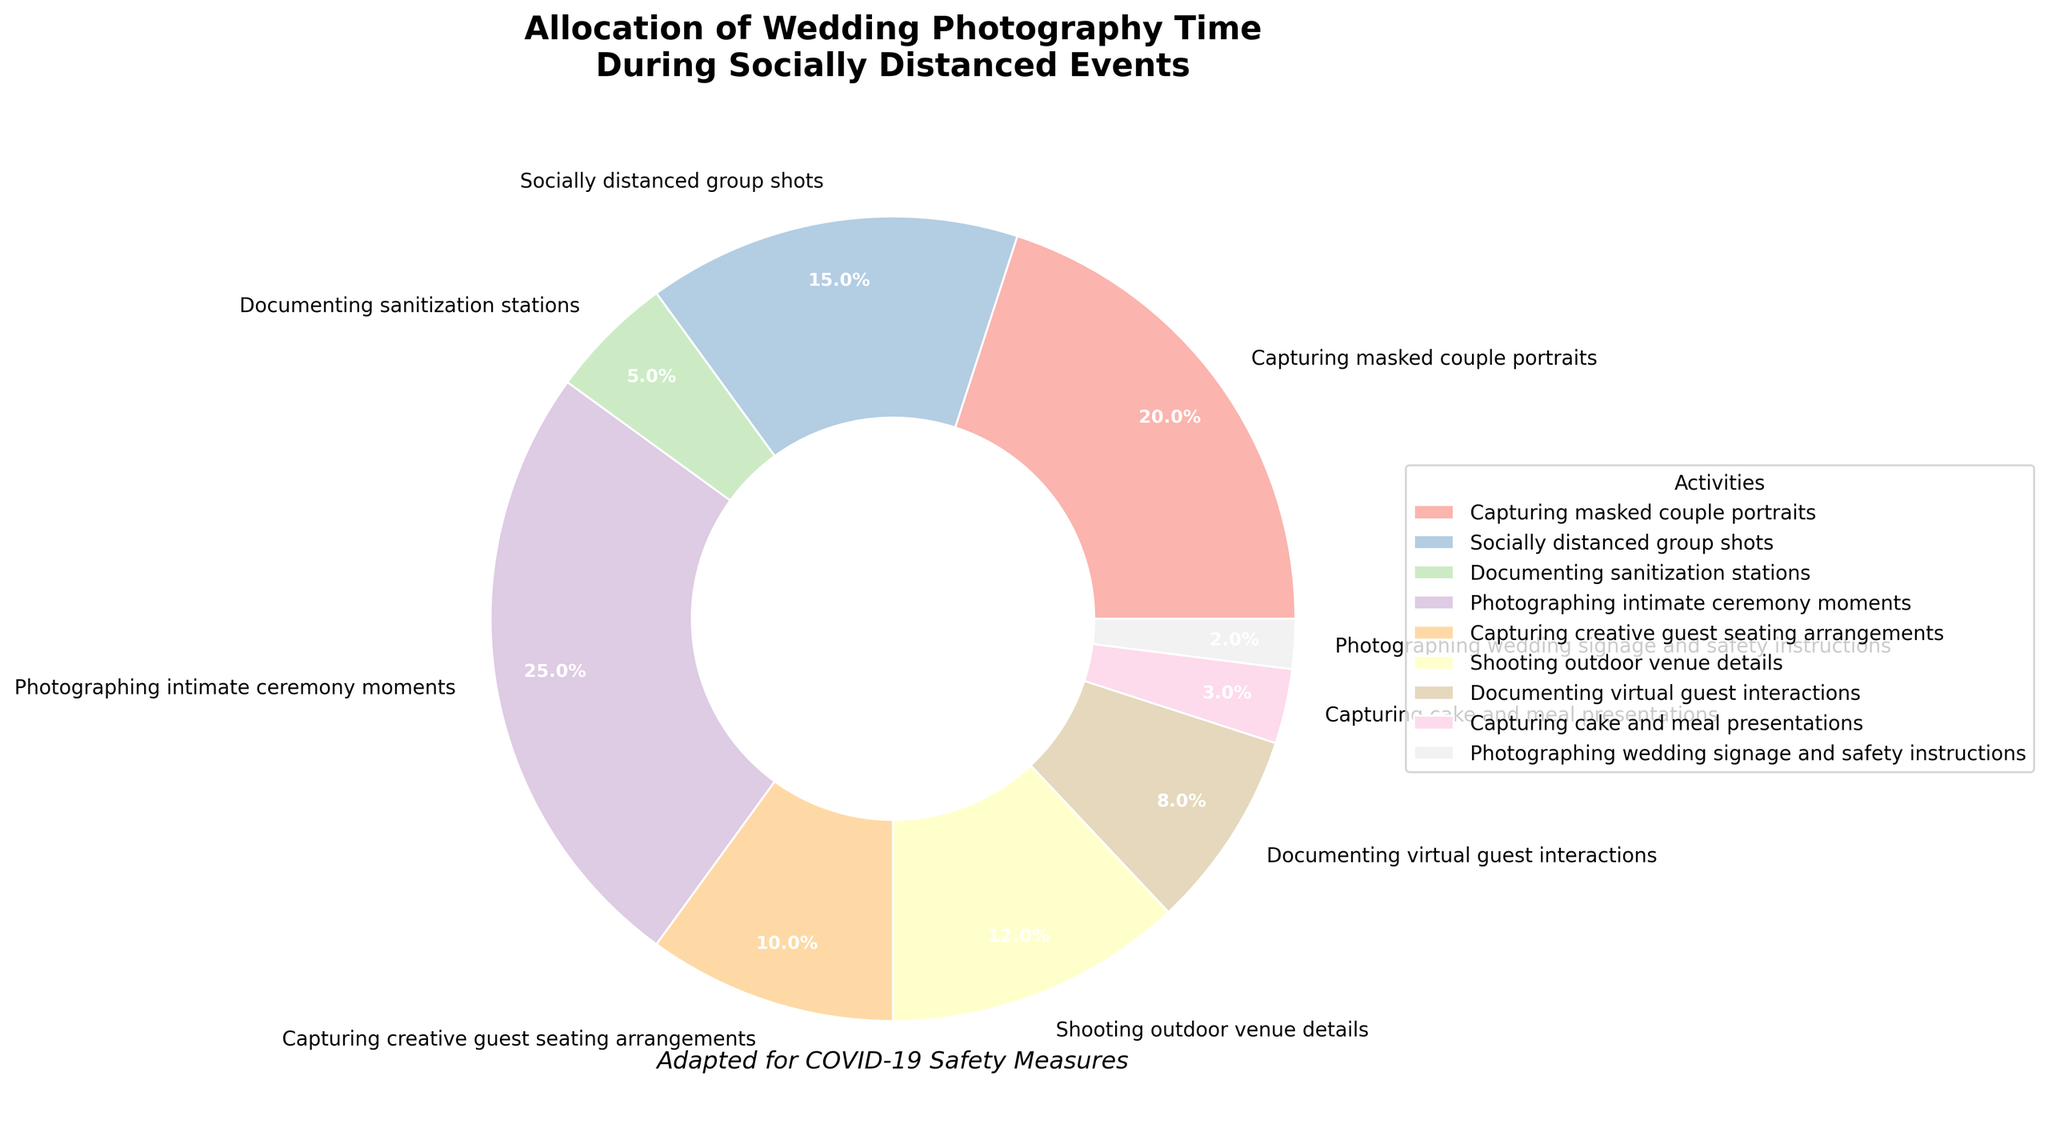Which activity takes up the largest percentage of wedding photography time? The pie chart shows that "Photographing intimate ceremony moments" occupies the largest slice of the pie at 25%.
Answer: Photographing intimate ceremony moments What is the combined percentage of time spent on "Capturing masked couple portraits" and "Socially distanced group shots"? The percentage of time spent on "Capturing masked couple portraits" is 20% and on "Socially distanced group shots" is 15%. Adding these together gives 20% + 15% = 35%.
Answer: 35% How does the time allocation for "Documenting sanitization stations" compare to "Photographing wedding signage and safety instructions"? "Documenting sanitization stations" takes up 5% of the time, while "Photographing wedding signage and safety instructions" takes up 2%. 5% is more than 2%.
Answer: 5% > 2% What's the total percentage of time allocated to "Photographing intimate ceremony moments," "Capturing creative guest seating arrangements," and "Shooting outdoor venue details"? The percentages are 25%, 10%, and 12% respectively. Adding them together gives 25% + 10% + 12% = 47%.
Answer: 47% Which activity uses the least amount of photography time? The pie chart shows the smallest slice belongs to "Photographing wedding signage and safety instructions" at 2%.
Answer: Photographing wedding signage and safety instructions How does the time spent on "Documenting virtual guest interactions" compare to "Capturing cake and meal presentations"? The time spent on "Documenting virtual guest interactions" is 8% and "Capturing cake and meal presentations" is 3%. 8% is more than 3%.
Answer: 8% > 3% What is the average time spent on "Capturing creative guest seating arrangements" and "Shooting outdoor venue details"? The time spent on these activities are 10% and 12% respectively. The average is (10% + 12%) / 2 = 11%.
Answer: 11% Combine the time allocations for "Capturing masked couple portraits," "Capturing creative guest seating arrangements," and "Documenting virtual guest interactions". What is the result? The time allocated to each are 20%, 10%, and 8% respectively. Summing these gives 20% + 10% + 8% = 38%.
Answer: 38% What percentage of time is allocated to activities that deal with guest interactions (both physical and virtual)? The activities are "Socially distanced group shots" (15%) and "Documenting virtual guest interactions" (8%). Adding these gives 15% + 8% = 23%.
Answer: 23% Is more time spent on "Shooting outdoor venue details" or "Capturing creative guest seating arrangements"? The pie chart indicates "Shooting outdoor venue details" is allocated 12%, while "Capturing creative guest seating arrangements" is 10%. 12% is more than 10%.
Answer: Shooting outdoor venue details 